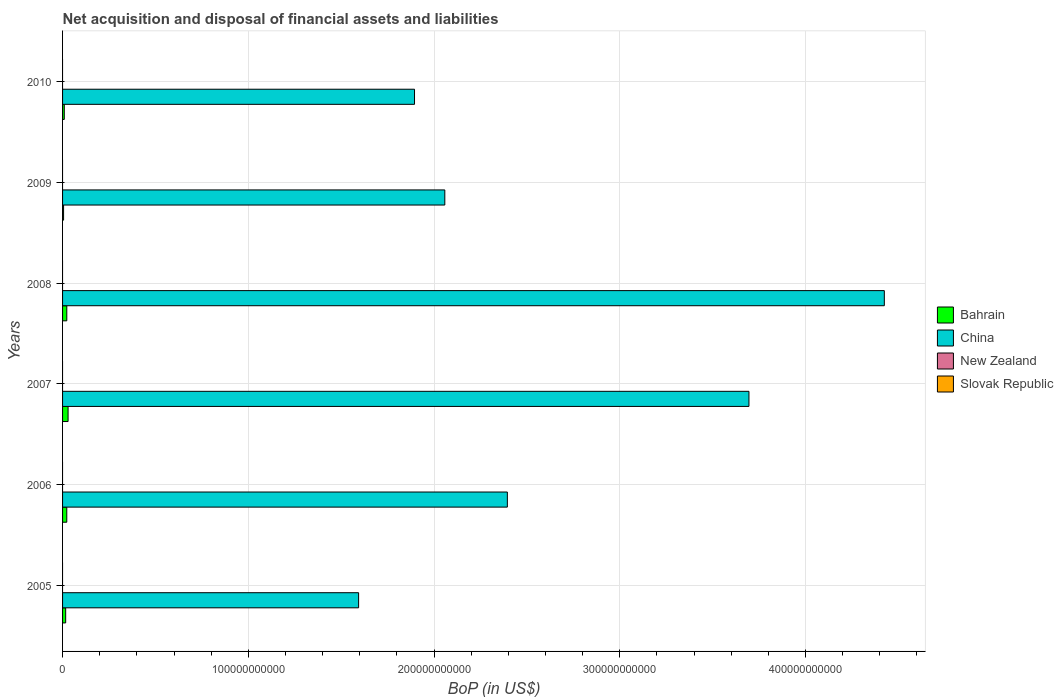How many different coloured bars are there?
Your answer should be compact. 2. How many groups of bars are there?
Provide a succinct answer. 6. Are the number of bars per tick equal to the number of legend labels?
Ensure brevity in your answer.  No. How many bars are there on the 6th tick from the bottom?
Give a very brief answer. 2. Across all years, what is the maximum Balance of Payments in China?
Your response must be concise. 4.42e+11. What is the total Balance of Payments in New Zealand in the graph?
Provide a short and direct response. 0. What is the difference between the Balance of Payments in China in 2005 and that in 2007?
Provide a short and direct response. -2.10e+11. What is the difference between the Balance of Payments in New Zealand in 2005 and the Balance of Payments in Slovak Republic in 2009?
Offer a very short reply. 0. What is the average Balance of Payments in Bahrain per year?
Give a very brief answer. 1.78e+09. In the year 2010, what is the difference between the Balance of Payments in Bahrain and Balance of Payments in China?
Give a very brief answer. -1.89e+11. In how many years, is the Balance of Payments in China greater than 400000000000 US$?
Your response must be concise. 1. What is the ratio of the Balance of Payments in China in 2008 to that in 2009?
Provide a short and direct response. 2.15. Is the difference between the Balance of Payments in Bahrain in 2005 and 2007 greater than the difference between the Balance of Payments in China in 2005 and 2007?
Keep it short and to the point. Yes. What is the difference between the highest and the second highest Balance of Payments in China?
Provide a short and direct response. 7.29e+1. What is the difference between the highest and the lowest Balance of Payments in China?
Your response must be concise. 2.83e+11. How many years are there in the graph?
Offer a terse response. 6. What is the difference between two consecutive major ticks on the X-axis?
Your response must be concise. 1.00e+11. Are the values on the major ticks of X-axis written in scientific E-notation?
Your answer should be very brief. No. Where does the legend appear in the graph?
Your response must be concise. Center right. What is the title of the graph?
Offer a very short reply. Net acquisition and disposal of financial assets and liabilities. Does "Netherlands" appear as one of the legend labels in the graph?
Provide a short and direct response. No. What is the label or title of the X-axis?
Your answer should be compact. BoP (in US$). What is the BoP (in US$) in Bahrain in 2005?
Offer a terse response. 1.67e+09. What is the BoP (in US$) of China in 2005?
Provide a succinct answer. 1.59e+11. What is the BoP (in US$) in Bahrain in 2006?
Give a very brief answer. 2.27e+09. What is the BoP (in US$) in China in 2006?
Give a very brief answer. 2.39e+11. What is the BoP (in US$) in Bahrain in 2007?
Offer a terse response. 2.97e+09. What is the BoP (in US$) of China in 2007?
Make the answer very short. 3.70e+11. What is the BoP (in US$) of Bahrain in 2008?
Provide a short and direct response. 2.28e+09. What is the BoP (in US$) in China in 2008?
Keep it short and to the point. 4.42e+11. What is the BoP (in US$) in New Zealand in 2008?
Keep it short and to the point. 0. What is the BoP (in US$) in Bahrain in 2009?
Make the answer very short. 5.44e+08. What is the BoP (in US$) of China in 2009?
Provide a short and direct response. 2.06e+11. What is the BoP (in US$) in Slovak Republic in 2009?
Make the answer very short. 0. What is the BoP (in US$) of Bahrain in 2010?
Offer a terse response. 9.27e+08. What is the BoP (in US$) in China in 2010?
Ensure brevity in your answer.  1.90e+11. What is the BoP (in US$) of New Zealand in 2010?
Provide a succinct answer. 0. What is the BoP (in US$) in Slovak Republic in 2010?
Your answer should be compact. 0. Across all years, what is the maximum BoP (in US$) of Bahrain?
Ensure brevity in your answer.  2.97e+09. Across all years, what is the maximum BoP (in US$) of China?
Provide a short and direct response. 4.42e+11. Across all years, what is the minimum BoP (in US$) in Bahrain?
Your answer should be very brief. 5.44e+08. Across all years, what is the minimum BoP (in US$) of China?
Give a very brief answer. 1.59e+11. What is the total BoP (in US$) of Bahrain in the graph?
Ensure brevity in your answer.  1.07e+1. What is the total BoP (in US$) in China in the graph?
Offer a very short reply. 1.61e+12. What is the total BoP (in US$) of New Zealand in the graph?
Your answer should be very brief. 0. What is the total BoP (in US$) in Slovak Republic in the graph?
Offer a very short reply. 0. What is the difference between the BoP (in US$) of Bahrain in 2005 and that in 2006?
Offer a terse response. -5.99e+08. What is the difference between the BoP (in US$) of China in 2005 and that in 2006?
Provide a short and direct response. -8.01e+1. What is the difference between the BoP (in US$) in Bahrain in 2005 and that in 2007?
Keep it short and to the point. -1.29e+09. What is the difference between the BoP (in US$) in China in 2005 and that in 2007?
Your answer should be very brief. -2.10e+11. What is the difference between the BoP (in US$) in Bahrain in 2005 and that in 2008?
Offer a terse response. -6.02e+08. What is the difference between the BoP (in US$) of China in 2005 and that in 2008?
Your answer should be compact. -2.83e+11. What is the difference between the BoP (in US$) in Bahrain in 2005 and that in 2009?
Keep it short and to the point. 1.13e+09. What is the difference between the BoP (in US$) of China in 2005 and that in 2009?
Your answer should be compact. -4.64e+1. What is the difference between the BoP (in US$) in Bahrain in 2005 and that in 2010?
Provide a short and direct response. 7.47e+08. What is the difference between the BoP (in US$) in China in 2005 and that in 2010?
Your answer should be very brief. -3.01e+1. What is the difference between the BoP (in US$) of Bahrain in 2006 and that in 2007?
Your answer should be compact. -6.93e+08. What is the difference between the BoP (in US$) in China in 2006 and that in 2007?
Your answer should be very brief. -1.30e+11. What is the difference between the BoP (in US$) in Bahrain in 2006 and that in 2008?
Your answer should be very brief. -3.25e+06. What is the difference between the BoP (in US$) in China in 2006 and that in 2008?
Make the answer very short. -2.03e+11. What is the difference between the BoP (in US$) in Bahrain in 2006 and that in 2009?
Provide a succinct answer. 1.73e+09. What is the difference between the BoP (in US$) in China in 2006 and that in 2009?
Keep it short and to the point. 3.37e+1. What is the difference between the BoP (in US$) in Bahrain in 2006 and that in 2010?
Provide a succinct answer. 1.35e+09. What is the difference between the BoP (in US$) in China in 2006 and that in 2010?
Your answer should be very brief. 5.00e+1. What is the difference between the BoP (in US$) of Bahrain in 2007 and that in 2008?
Offer a terse response. 6.90e+08. What is the difference between the BoP (in US$) in China in 2007 and that in 2008?
Provide a succinct answer. -7.29e+1. What is the difference between the BoP (in US$) in Bahrain in 2007 and that in 2009?
Provide a short and direct response. 2.42e+09. What is the difference between the BoP (in US$) of China in 2007 and that in 2009?
Your answer should be very brief. 1.64e+11. What is the difference between the BoP (in US$) in Bahrain in 2007 and that in 2010?
Ensure brevity in your answer.  2.04e+09. What is the difference between the BoP (in US$) in China in 2007 and that in 2010?
Give a very brief answer. 1.80e+11. What is the difference between the BoP (in US$) in Bahrain in 2008 and that in 2009?
Provide a succinct answer. 1.73e+09. What is the difference between the BoP (in US$) of China in 2008 and that in 2009?
Keep it short and to the point. 2.37e+11. What is the difference between the BoP (in US$) in Bahrain in 2008 and that in 2010?
Give a very brief answer. 1.35e+09. What is the difference between the BoP (in US$) in China in 2008 and that in 2010?
Offer a terse response. 2.53e+11. What is the difference between the BoP (in US$) in Bahrain in 2009 and that in 2010?
Keep it short and to the point. -3.83e+08. What is the difference between the BoP (in US$) in China in 2009 and that in 2010?
Provide a succinct answer. 1.63e+1. What is the difference between the BoP (in US$) in Bahrain in 2005 and the BoP (in US$) in China in 2006?
Provide a succinct answer. -2.38e+11. What is the difference between the BoP (in US$) in Bahrain in 2005 and the BoP (in US$) in China in 2007?
Provide a succinct answer. -3.68e+11. What is the difference between the BoP (in US$) of Bahrain in 2005 and the BoP (in US$) of China in 2008?
Offer a very short reply. -4.41e+11. What is the difference between the BoP (in US$) in Bahrain in 2005 and the BoP (in US$) in China in 2009?
Your answer should be compact. -2.04e+11. What is the difference between the BoP (in US$) of Bahrain in 2005 and the BoP (in US$) of China in 2010?
Provide a short and direct response. -1.88e+11. What is the difference between the BoP (in US$) of Bahrain in 2006 and the BoP (in US$) of China in 2007?
Offer a very short reply. -3.67e+11. What is the difference between the BoP (in US$) in Bahrain in 2006 and the BoP (in US$) in China in 2008?
Keep it short and to the point. -4.40e+11. What is the difference between the BoP (in US$) in Bahrain in 2006 and the BoP (in US$) in China in 2009?
Ensure brevity in your answer.  -2.04e+11. What is the difference between the BoP (in US$) in Bahrain in 2006 and the BoP (in US$) in China in 2010?
Your answer should be compact. -1.87e+11. What is the difference between the BoP (in US$) in Bahrain in 2007 and the BoP (in US$) in China in 2008?
Keep it short and to the point. -4.39e+11. What is the difference between the BoP (in US$) of Bahrain in 2007 and the BoP (in US$) of China in 2009?
Ensure brevity in your answer.  -2.03e+11. What is the difference between the BoP (in US$) in Bahrain in 2007 and the BoP (in US$) in China in 2010?
Your response must be concise. -1.87e+11. What is the difference between the BoP (in US$) of Bahrain in 2008 and the BoP (in US$) of China in 2009?
Ensure brevity in your answer.  -2.04e+11. What is the difference between the BoP (in US$) of Bahrain in 2008 and the BoP (in US$) of China in 2010?
Give a very brief answer. -1.87e+11. What is the difference between the BoP (in US$) of Bahrain in 2009 and the BoP (in US$) of China in 2010?
Provide a short and direct response. -1.89e+11. What is the average BoP (in US$) in Bahrain per year?
Offer a very short reply. 1.78e+09. What is the average BoP (in US$) in China per year?
Keep it short and to the point. 2.68e+11. In the year 2005, what is the difference between the BoP (in US$) of Bahrain and BoP (in US$) of China?
Provide a succinct answer. -1.58e+11. In the year 2006, what is the difference between the BoP (in US$) in Bahrain and BoP (in US$) in China?
Provide a short and direct response. -2.37e+11. In the year 2007, what is the difference between the BoP (in US$) in Bahrain and BoP (in US$) in China?
Provide a short and direct response. -3.67e+11. In the year 2008, what is the difference between the BoP (in US$) of Bahrain and BoP (in US$) of China?
Your answer should be very brief. -4.40e+11. In the year 2009, what is the difference between the BoP (in US$) of Bahrain and BoP (in US$) of China?
Make the answer very short. -2.05e+11. In the year 2010, what is the difference between the BoP (in US$) of Bahrain and BoP (in US$) of China?
Offer a terse response. -1.89e+11. What is the ratio of the BoP (in US$) of Bahrain in 2005 to that in 2006?
Offer a very short reply. 0.74. What is the ratio of the BoP (in US$) in China in 2005 to that in 2006?
Make the answer very short. 0.67. What is the ratio of the BoP (in US$) in Bahrain in 2005 to that in 2007?
Offer a very short reply. 0.56. What is the ratio of the BoP (in US$) of China in 2005 to that in 2007?
Offer a terse response. 0.43. What is the ratio of the BoP (in US$) in Bahrain in 2005 to that in 2008?
Provide a succinct answer. 0.74. What is the ratio of the BoP (in US$) of China in 2005 to that in 2008?
Your answer should be compact. 0.36. What is the ratio of the BoP (in US$) of Bahrain in 2005 to that in 2009?
Provide a short and direct response. 3.08. What is the ratio of the BoP (in US$) of China in 2005 to that in 2009?
Offer a very short reply. 0.77. What is the ratio of the BoP (in US$) of Bahrain in 2005 to that in 2010?
Your response must be concise. 1.81. What is the ratio of the BoP (in US$) of China in 2005 to that in 2010?
Provide a short and direct response. 0.84. What is the ratio of the BoP (in US$) in Bahrain in 2006 to that in 2007?
Offer a terse response. 0.77. What is the ratio of the BoP (in US$) of China in 2006 to that in 2007?
Keep it short and to the point. 0.65. What is the ratio of the BoP (in US$) of Bahrain in 2006 to that in 2008?
Make the answer very short. 1. What is the ratio of the BoP (in US$) of China in 2006 to that in 2008?
Make the answer very short. 0.54. What is the ratio of the BoP (in US$) in Bahrain in 2006 to that in 2009?
Give a very brief answer. 4.18. What is the ratio of the BoP (in US$) in China in 2006 to that in 2009?
Make the answer very short. 1.16. What is the ratio of the BoP (in US$) of Bahrain in 2006 to that in 2010?
Provide a short and direct response. 2.45. What is the ratio of the BoP (in US$) in China in 2006 to that in 2010?
Provide a short and direct response. 1.26. What is the ratio of the BoP (in US$) in Bahrain in 2007 to that in 2008?
Your response must be concise. 1.3. What is the ratio of the BoP (in US$) in China in 2007 to that in 2008?
Give a very brief answer. 0.84. What is the ratio of the BoP (in US$) in Bahrain in 2007 to that in 2009?
Your response must be concise. 5.45. What is the ratio of the BoP (in US$) in China in 2007 to that in 2009?
Offer a terse response. 1.8. What is the ratio of the BoP (in US$) of Bahrain in 2007 to that in 2010?
Ensure brevity in your answer.  3.2. What is the ratio of the BoP (in US$) in China in 2007 to that in 2010?
Offer a very short reply. 1.95. What is the ratio of the BoP (in US$) in Bahrain in 2008 to that in 2009?
Give a very brief answer. 4.18. What is the ratio of the BoP (in US$) in China in 2008 to that in 2009?
Offer a very short reply. 2.15. What is the ratio of the BoP (in US$) of Bahrain in 2008 to that in 2010?
Make the answer very short. 2.46. What is the ratio of the BoP (in US$) in China in 2008 to that in 2010?
Your answer should be very brief. 2.33. What is the ratio of the BoP (in US$) in Bahrain in 2009 to that in 2010?
Provide a succinct answer. 0.59. What is the ratio of the BoP (in US$) of China in 2009 to that in 2010?
Your response must be concise. 1.09. What is the difference between the highest and the second highest BoP (in US$) in Bahrain?
Provide a short and direct response. 6.90e+08. What is the difference between the highest and the second highest BoP (in US$) of China?
Your response must be concise. 7.29e+1. What is the difference between the highest and the lowest BoP (in US$) of Bahrain?
Your answer should be very brief. 2.42e+09. What is the difference between the highest and the lowest BoP (in US$) in China?
Provide a short and direct response. 2.83e+11. 